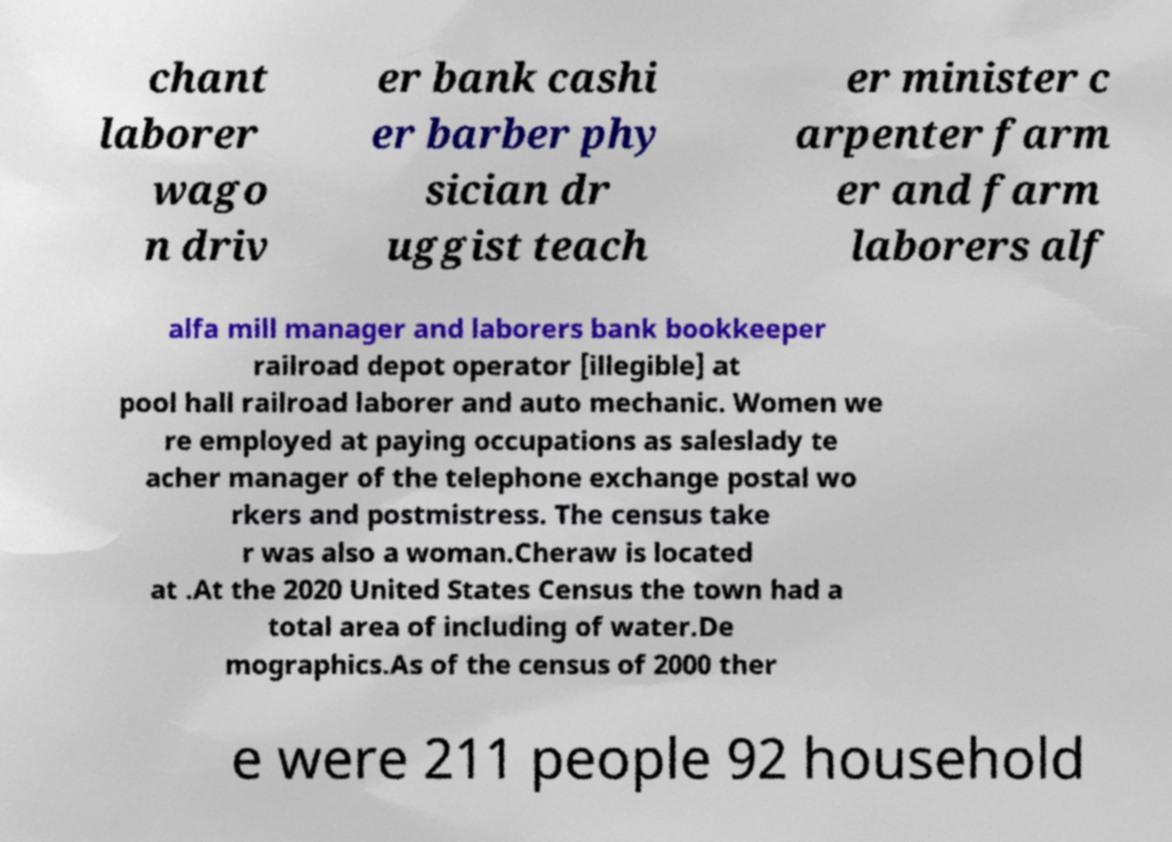Please identify and transcribe the text found in this image. chant laborer wago n driv er bank cashi er barber phy sician dr uggist teach er minister c arpenter farm er and farm laborers alf alfa mill manager and laborers bank bookkeeper railroad depot operator [illegible] at pool hall railroad laborer and auto mechanic. Women we re employed at paying occupations as saleslady te acher manager of the telephone exchange postal wo rkers and postmistress. The census take r was also a woman.Cheraw is located at .At the 2020 United States Census the town had a total area of including of water.De mographics.As of the census of 2000 ther e were 211 people 92 household 